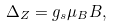<formula> <loc_0><loc_0><loc_500><loc_500>\Delta _ { Z } = g _ { s } \mu _ { B } B ,</formula> 